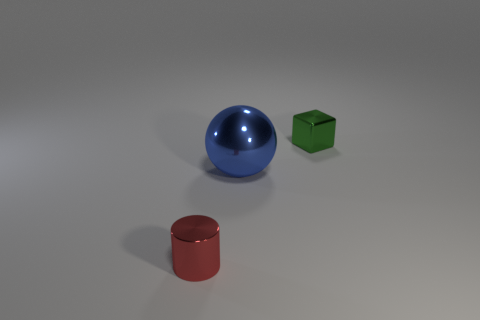There is another large thing that is the same material as the green thing; what shape is it? sphere 